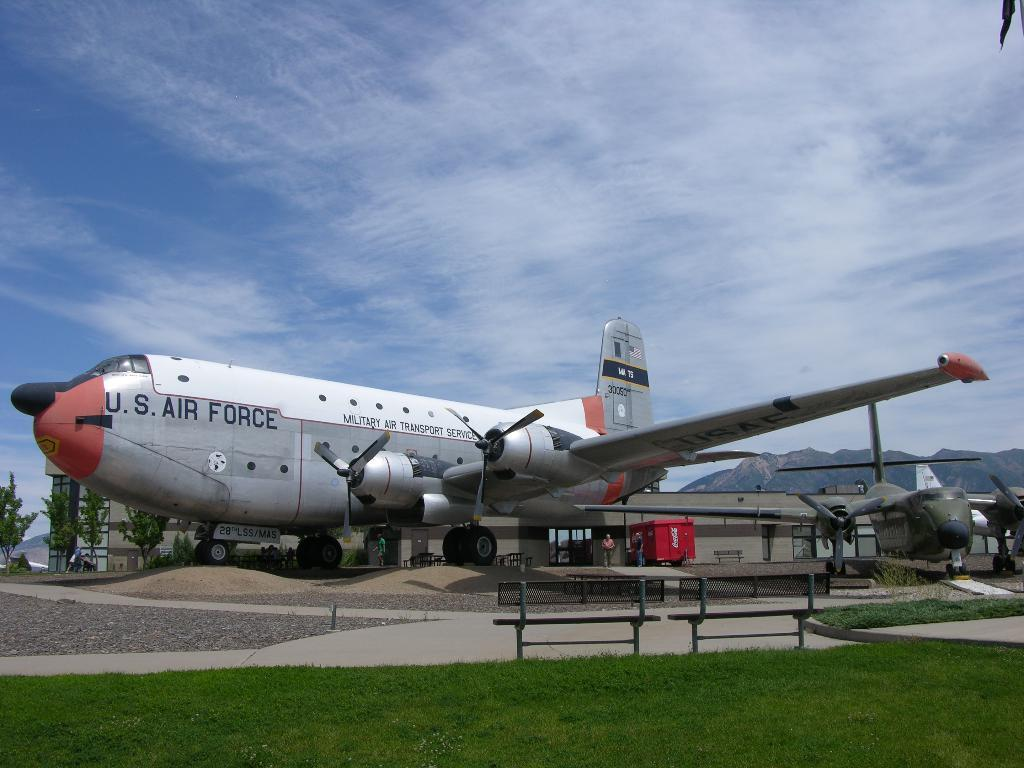What is the main subject of the image? The main subject of the image is a plane. Where is the plane located in the image? The plane is on the road in the image. What other structures or objects can be seen in the image? There is a shed, a bench, and grass visible in the image. What is visible at the top of the image? The sky and clouds are visible at the top of the image. How many boys are performing magic tricks in the crowd in the image? There are no boys performing magic tricks or any crowd present in the image; it features a plane on the road with a shed, bench, and grass in the background. 